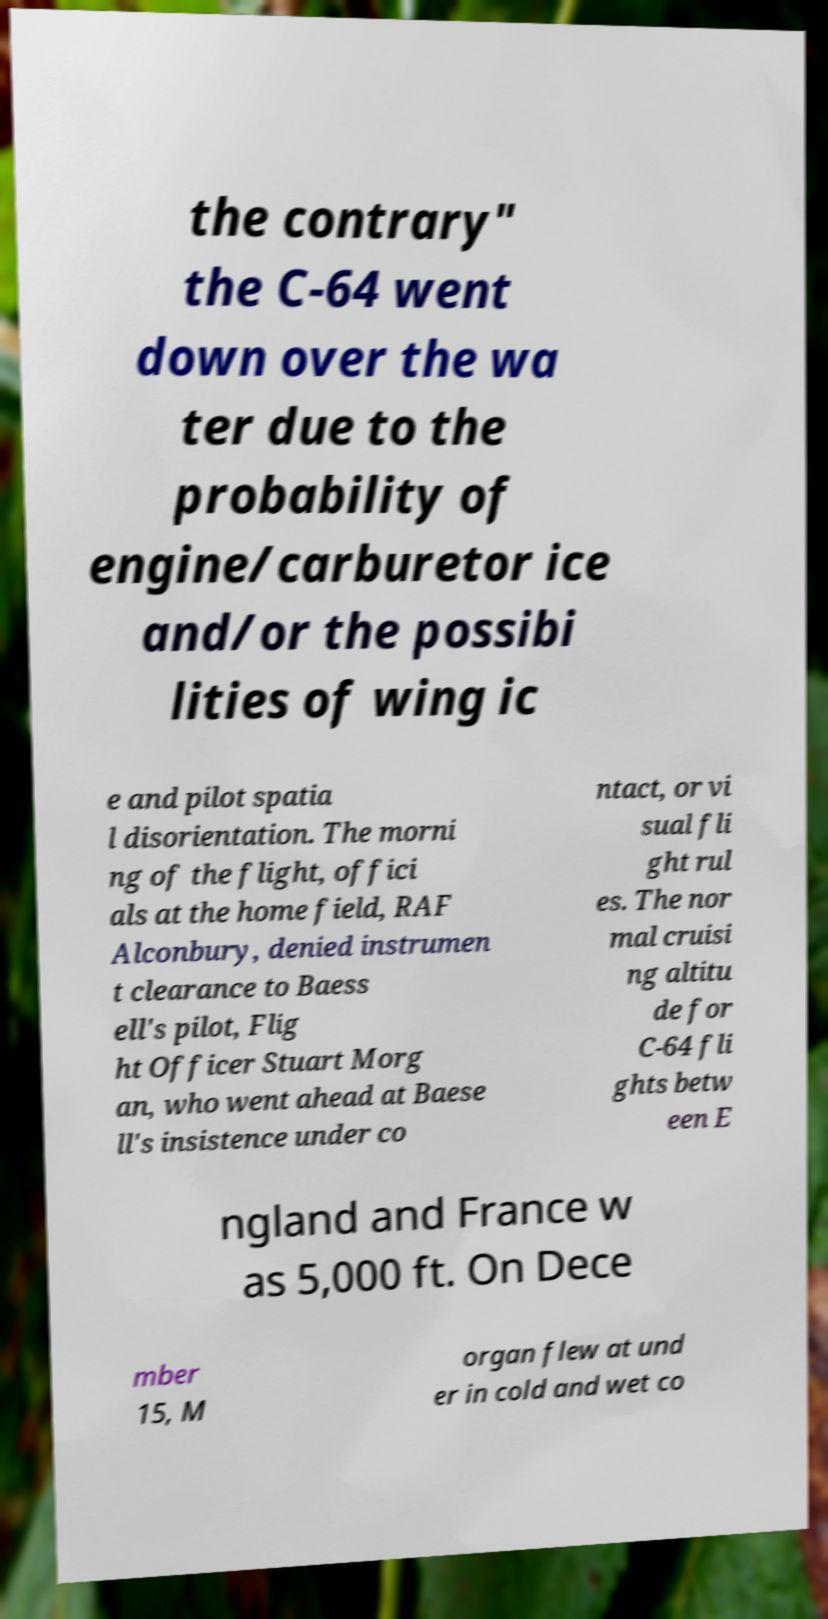Can you accurately transcribe the text from the provided image for me? the contrary" the C-64 went down over the wa ter due to the probability of engine/carburetor ice and/or the possibi lities of wing ic e and pilot spatia l disorientation. The morni ng of the flight, offici als at the home field, RAF Alconbury, denied instrumen t clearance to Baess ell's pilot, Flig ht Officer Stuart Morg an, who went ahead at Baese ll's insistence under co ntact, or vi sual fli ght rul es. The nor mal cruisi ng altitu de for C-64 fli ghts betw een E ngland and France w as 5,000 ft. On Dece mber 15, M organ flew at und er in cold and wet co 